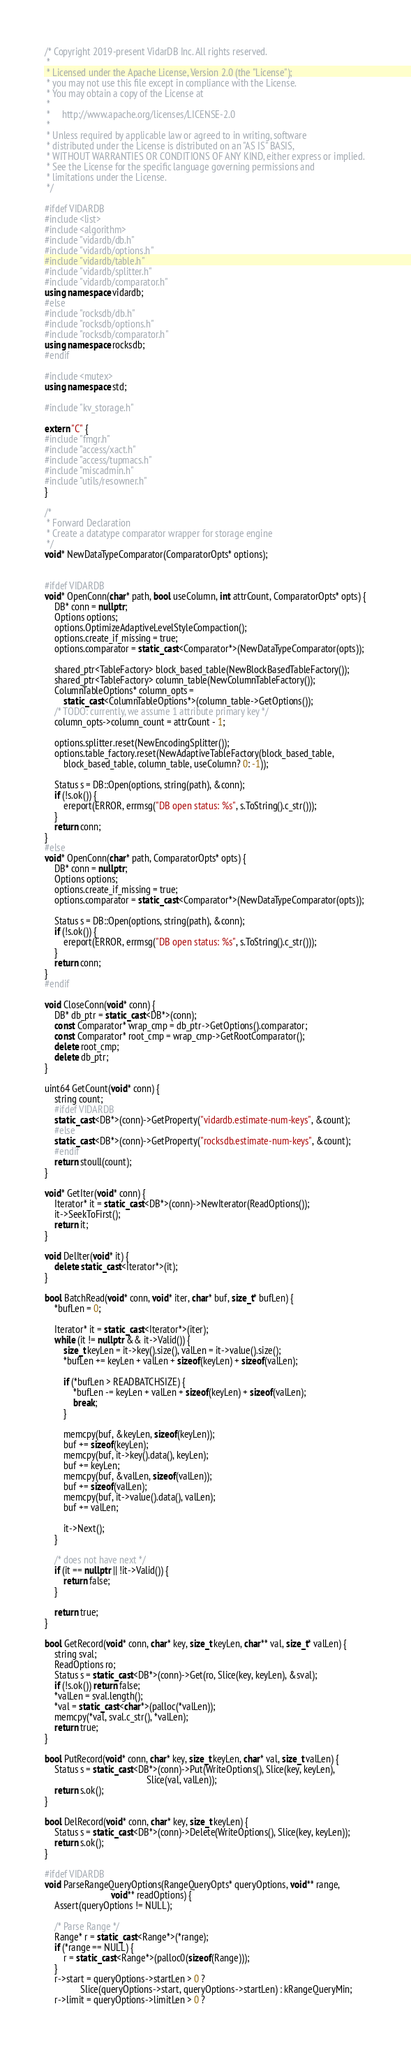<code> <loc_0><loc_0><loc_500><loc_500><_C++_>/* Copyright 2019-present VidarDB Inc. All rights reserved.
 *
 * Licensed under the Apache License, Version 2.0 (the "License");
 * you may not use this file except in compliance with the License.
 * You may obtain a copy of the License at
 *
 *     http://www.apache.org/licenses/LICENSE-2.0
 *
 * Unless required by applicable law or agreed to in writing, software
 * distributed under the License is distributed on an "AS IS" BASIS,
 * WITHOUT WARRANTIES OR CONDITIONS OF ANY KIND, either express or implied.
 * See the License for the specific language governing permissions and
 * limitations under the License.
 */

#ifdef VIDARDB
#include <list>
#include <algorithm>
#include "vidardb/db.h"
#include "vidardb/options.h"
#include "vidardb/table.h"
#include "vidardb/splitter.h"
#include "vidardb/comparator.h"
using namespace vidardb;
#else
#include "rocksdb/db.h"
#include "rocksdb/options.h"
#include "rocksdb/comparator.h"
using namespace rocksdb;
#endif

#include <mutex>
using namespace std;

#include "kv_storage.h"

extern "C" {
#include "fmgr.h"
#include "access/xact.h"
#include "access/tupmacs.h"
#include "miscadmin.h"
#include "utils/resowner.h"
}

/*
 * Forward Declaration
 * Create a datatype comparator wrapper for storage engine
 */
void* NewDataTypeComparator(ComparatorOpts* options);


#ifdef VIDARDB
void* OpenConn(char* path, bool useColumn, int attrCount, ComparatorOpts* opts) {
    DB* conn = nullptr;
    Options options;
    options.OptimizeAdaptiveLevelStyleCompaction();
    options.create_if_missing = true;
    options.comparator = static_cast<Comparator*>(NewDataTypeComparator(opts));

    shared_ptr<TableFactory> block_based_table(NewBlockBasedTableFactory());
    shared_ptr<TableFactory> column_table(NewColumnTableFactory());
    ColumnTableOptions* column_opts =
        static_cast<ColumnTableOptions*>(column_table->GetOptions());
    /* TODO: currently, we assume 1 attribute primary key */
    column_opts->column_count = attrCount - 1;

    options.splitter.reset(NewEncodingSplitter());
    options.table_factory.reset(NewAdaptiveTableFactory(block_based_table,
        block_based_table, column_table, useColumn? 0: -1));

    Status s = DB::Open(options, string(path), &conn);
    if (!s.ok()) {
        ereport(ERROR, errmsg("DB open status: %s", s.ToString().c_str()));
    }
    return conn;
}
#else
void* OpenConn(char* path, ComparatorOpts* opts) {
    DB* conn = nullptr;
    Options options;
    options.create_if_missing = true;
    options.comparator = static_cast<Comparator*>(NewDataTypeComparator(opts));

    Status s = DB::Open(options, string(path), &conn);
    if (!s.ok()) {
        ereport(ERROR, errmsg("DB open status: %s", s.ToString().c_str()));
    }
    return conn;
}
#endif

void CloseConn(void* conn) {
    DB* db_ptr = static_cast<DB*>(conn);
    const Comparator* wrap_cmp = db_ptr->GetOptions().comparator;
    const Comparator* root_cmp = wrap_cmp->GetRootComparator();
    delete root_cmp;
    delete db_ptr;
}

uint64 GetCount(void* conn) {
    string count;
    #ifdef VIDARDB
    static_cast<DB*>(conn)->GetProperty("vidardb.estimate-num-keys", &count);
    #else
    static_cast<DB*>(conn)->GetProperty("rocksdb.estimate-num-keys", &count);
    #endif
    return stoull(count);
}

void* GetIter(void* conn) {
    Iterator* it = static_cast<DB*>(conn)->NewIterator(ReadOptions());
    it->SeekToFirst();
    return it;
}

void DelIter(void* it) {
    delete static_cast<Iterator*>(it);
}

bool BatchRead(void* conn, void* iter, char* buf, size_t* bufLen) {
    *bufLen = 0;

    Iterator* it = static_cast<Iterator*>(iter);
    while (it != nullptr && it->Valid()) {
        size_t keyLen = it->key().size(), valLen = it->value().size();
        *bufLen += keyLen + valLen + sizeof(keyLen) + sizeof(valLen);

        if (*bufLen > READBATCHSIZE) {
            *bufLen -= keyLen + valLen + sizeof(keyLen) + sizeof(valLen);
            break;
        }

        memcpy(buf, &keyLen, sizeof(keyLen));
        buf += sizeof(keyLen);
        memcpy(buf, it->key().data(), keyLen);
        buf += keyLen;
        memcpy(buf, &valLen, sizeof(valLen));
        buf += sizeof(valLen);
        memcpy(buf, it->value().data(), valLen);
        buf += valLen;

        it->Next();
    }

    /* does not have next */
    if (it == nullptr || !it->Valid()) {
        return false;
    }

    return true;
}

bool GetRecord(void* conn, char* key, size_t keyLen, char** val, size_t* valLen) {
    string sval;
    ReadOptions ro;
    Status s = static_cast<DB*>(conn)->Get(ro, Slice(key, keyLen), &sval);
    if (!s.ok()) return false;
    *valLen = sval.length();
    *val = static_cast<char*>(palloc(*valLen));
    memcpy(*val, sval.c_str(), *valLen);
    return true;
}

bool PutRecord(void* conn, char* key, size_t keyLen, char* val, size_t valLen) {
    Status s = static_cast<DB*>(conn)->Put(WriteOptions(), Slice(key, keyLen),
                                           Slice(val, valLen));
    return s.ok();
}

bool DelRecord(void* conn, char* key, size_t keyLen) {
    Status s = static_cast<DB*>(conn)->Delete(WriteOptions(), Slice(key, keyLen));
    return s.ok();
}

#ifdef VIDARDB
void ParseRangeQueryOptions(RangeQueryOpts* queryOptions, void** range,
                            void** readOptions) {
    Assert(queryOptions != NULL);

    /* Parse Range */
    Range* r = static_cast<Range*>(*range);
    if (*range == NULL) {
        r = static_cast<Range*>(palloc0(sizeof(Range)));
    }
    r->start = queryOptions->startLen > 0 ?
               Slice(queryOptions->start, queryOptions->startLen) : kRangeQueryMin;
    r->limit = queryOptions->limitLen > 0 ?</code> 